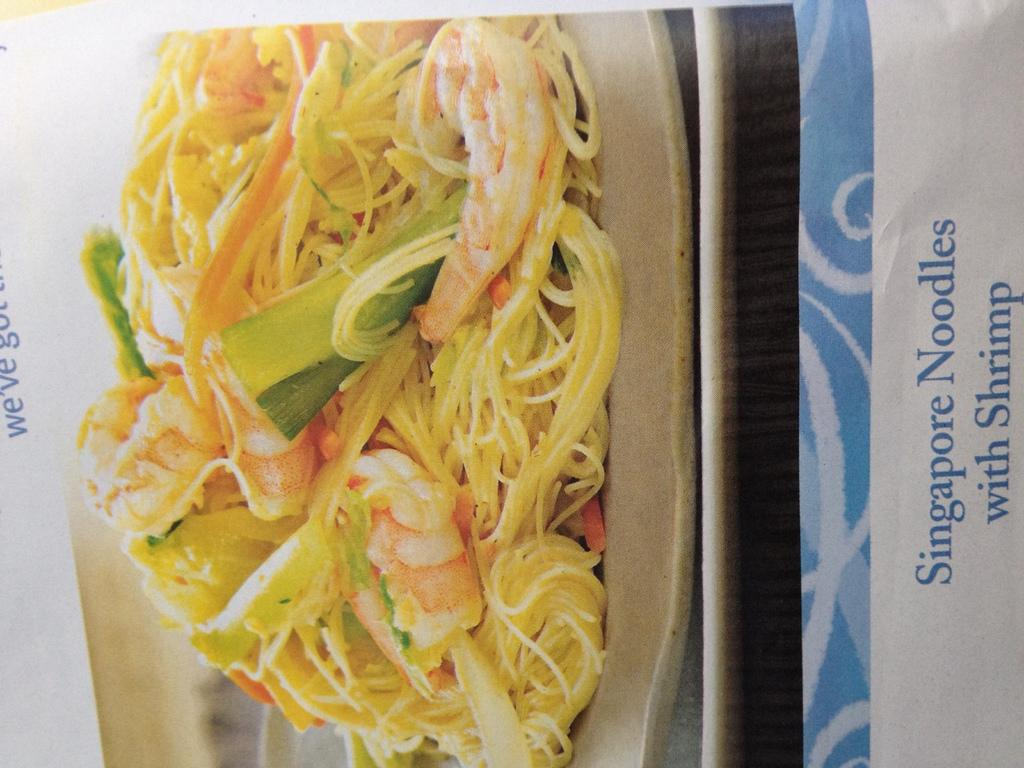What is featured in the image? There is a poster in the image. What is depicted on the poster? The poster contains a plate with food. What caused the plate to be placed on the poster? There is no information provided about the cause of the plate being placed on the poster. 